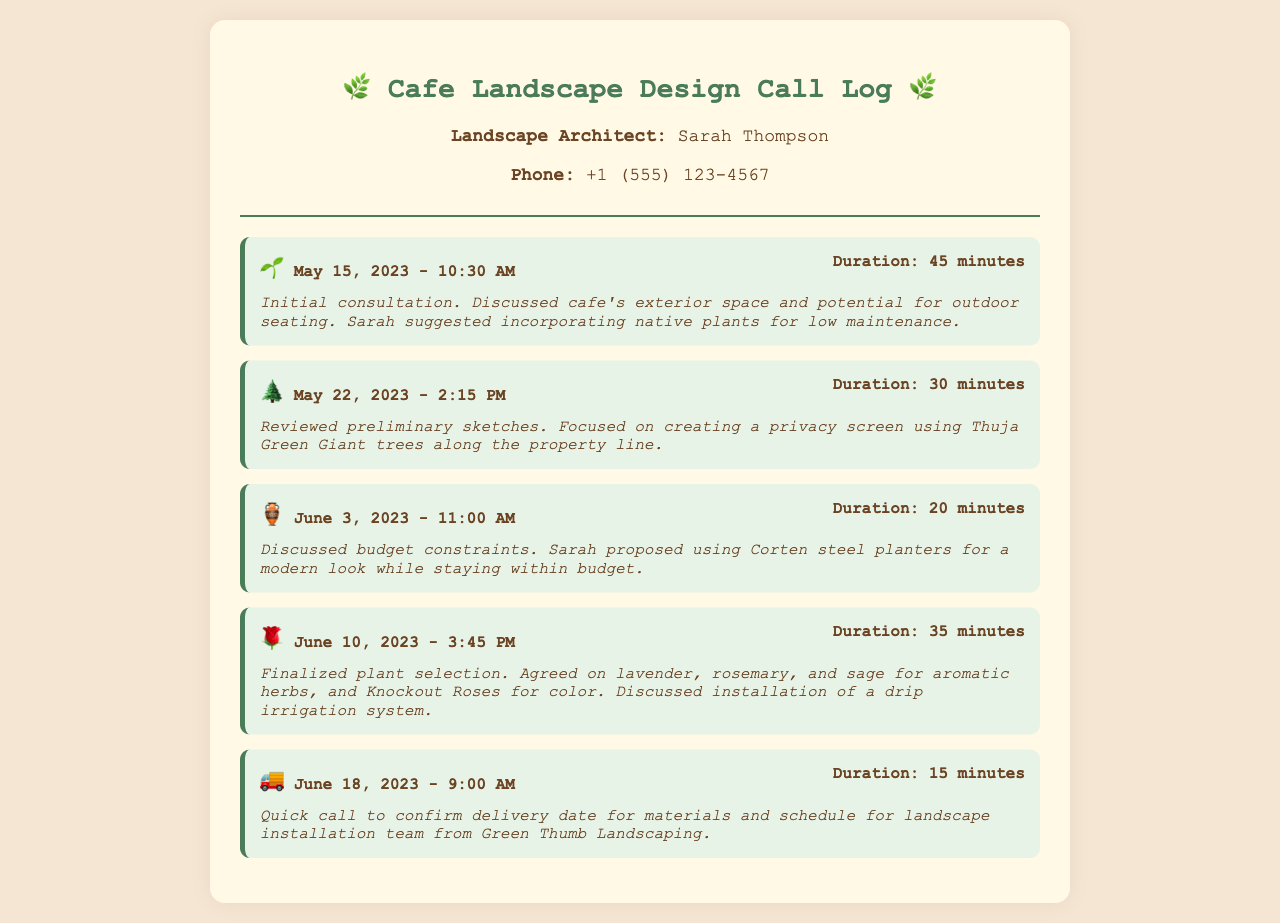what is the name of the landscape architect? The landscape architect's name is listed in the contact information of the document.
Answer: Sarah Thompson what date did the initial consultation take place? The date of the initial consultation is provided in the first call entry.
Answer: May 15, 2023 how long was the call on June 10, 2023? The duration of the call on June 10, 2023 is mentioned in the call entry.
Answer: 35 minutes what plants were finalized during the June 10 call? The finalized plants are listed in the notes of the June 10 call entry.
Answer: lavender, rosemary, sage, and Knockout Roses what is the main focus of the second call on May 22, 2023? The focus of the second call is provided in the notes of that entry.
Answer: privacy screen what type of planters did Sarah propose on June 3, 2023? The type of planters proposed is specified in the notes of the June 3 call entry.
Answer: Corten steel planters when was the delivery date for materials confirmed? The confirmation of the delivery date is mentioned in the notes of the June 18 call entry.
Answer: June 18, 2023 how many calls were made regarding the landscape design? The total number of calls made is determined by counting the call entries in the document.
Answer: 5 